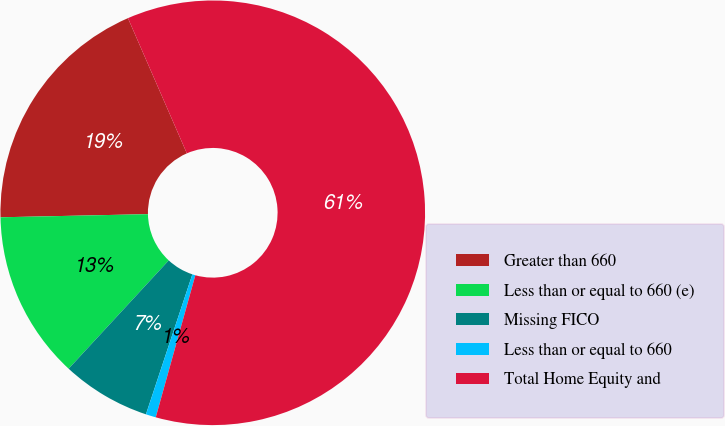Convert chart to OTSL. <chart><loc_0><loc_0><loc_500><loc_500><pie_chart><fcel>Greater than 660<fcel>Less than or equal to 660 (e)<fcel>Missing FICO<fcel>Less than or equal to 660<fcel>Total Home Equity and<nl><fcel>18.8%<fcel>12.79%<fcel>6.78%<fcel>0.77%<fcel>60.87%<nl></chart> 